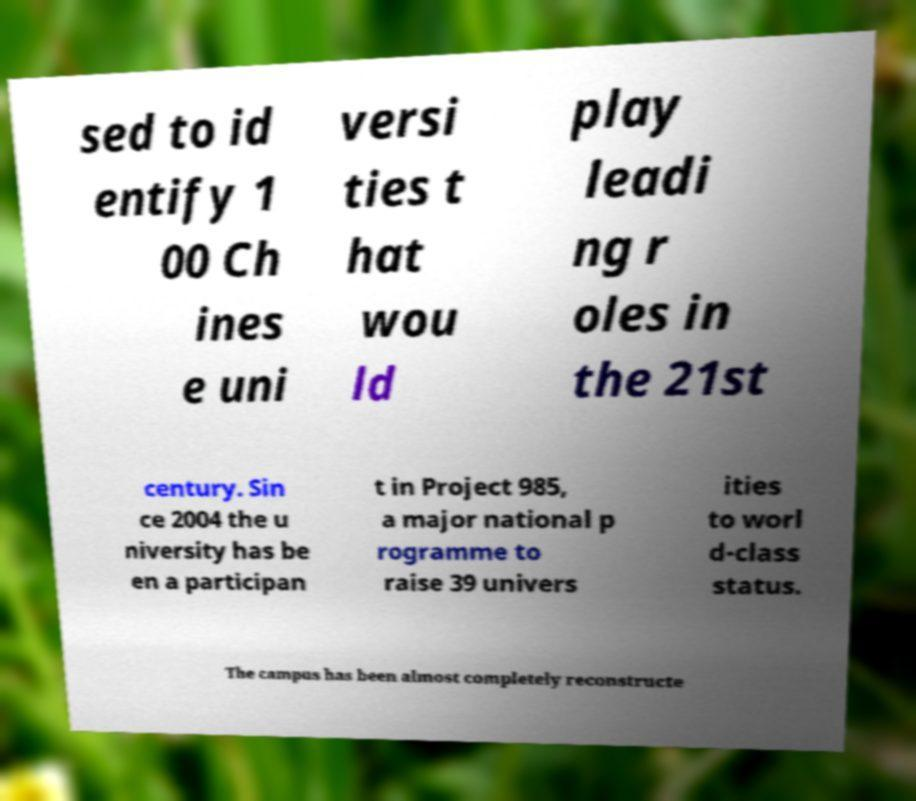What messages or text are displayed in this image? I need them in a readable, typed format. sed to id entify 1 00 Ch ines e uni versi ties t hat wou ld play leadi ng r oles in the 21st century. Sin ce 2004 the u niversity has be en a participan t in Project 985, a major national p rogramme to raise 39 univers ities to worl d-class status. The campus has been almost completely reconstructe 